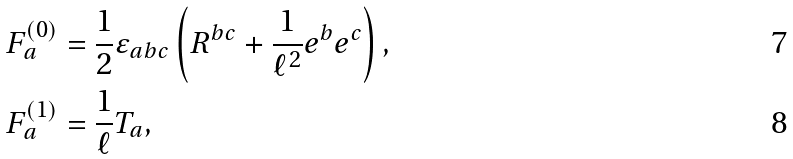Convert formula to latex. <formula><loc_0><loc_0><loc_500><loc_500>F _ { a } ^ { \left ( 0 \right ) } & = \frac { 1 } { 2 } \varepsilon _ { a b c } \left ( R ^ { b c } + \frac { 1 } { \ell ^ { 2 } } e ^ { b } e ^ { c } \right ) , \\ F _ { a } ^ { \left ( 1 \right ) } & = \frac { 1 } { \ell } T _ { a } ,</formula> 